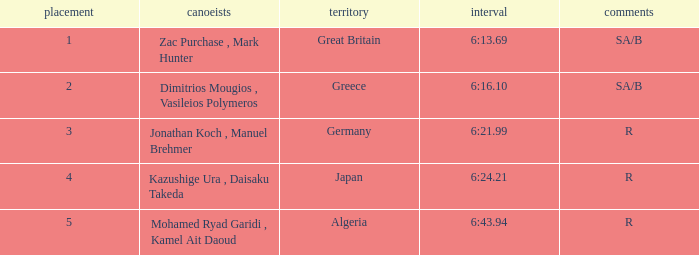What's the time of Rank 3? 6:21.99. 